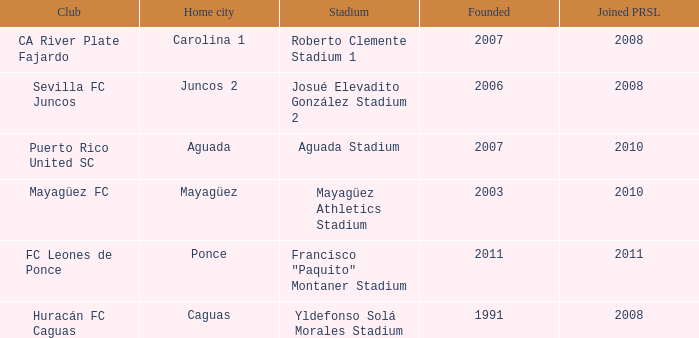What is the earliest founded when the home city is mayagüez? 2003.0. 